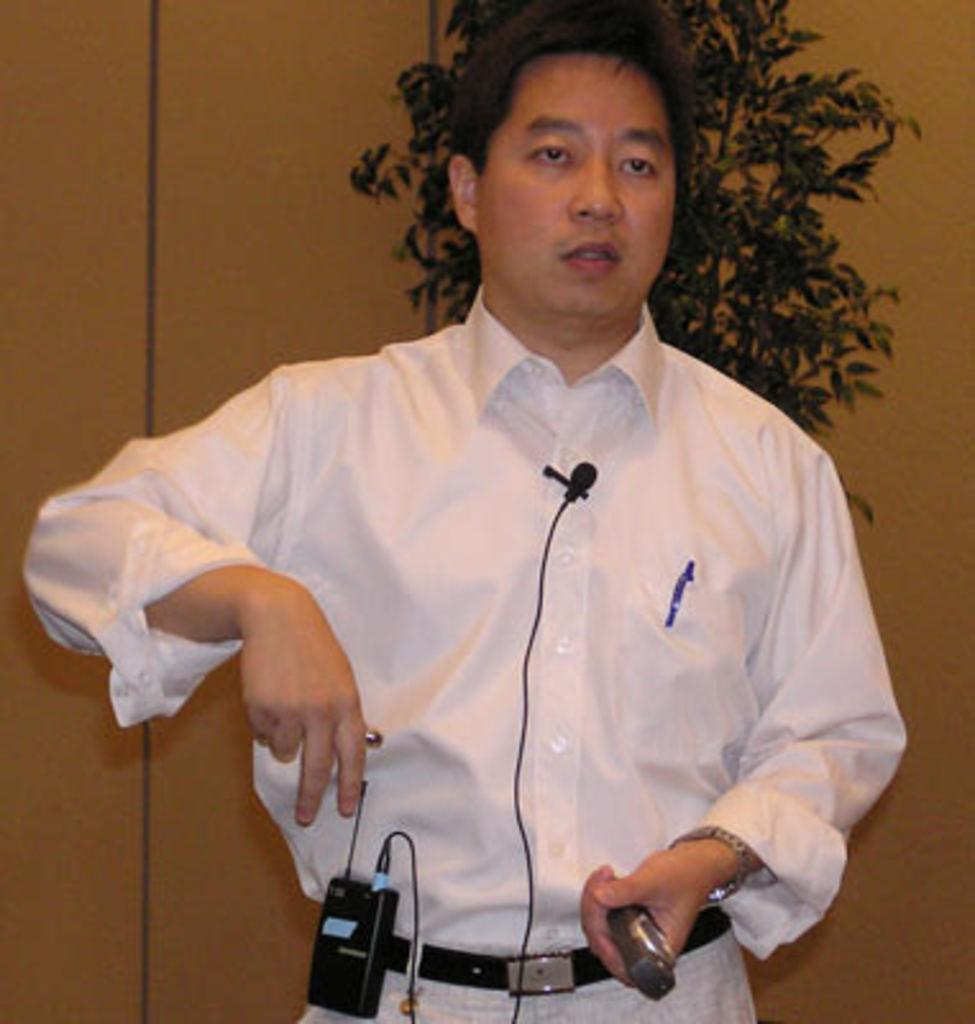Who is present in the image? There is a man in the image. What is the man wearing? The man is wearing a shirt. What is the man holding in the image? The man is holding an object. What is the man's posture in the image? The man is standing. What can be seen in the background of the image? There is a wall and a plant in the background of the image. What type of insect can be seen crawling on the man's shirt in the image? There is no insect present on the man's shirt in the image. What is the man using to lift heavy objects in the image? The man is not using any object to lift heavy objects in the image; he is simply holding an object. 